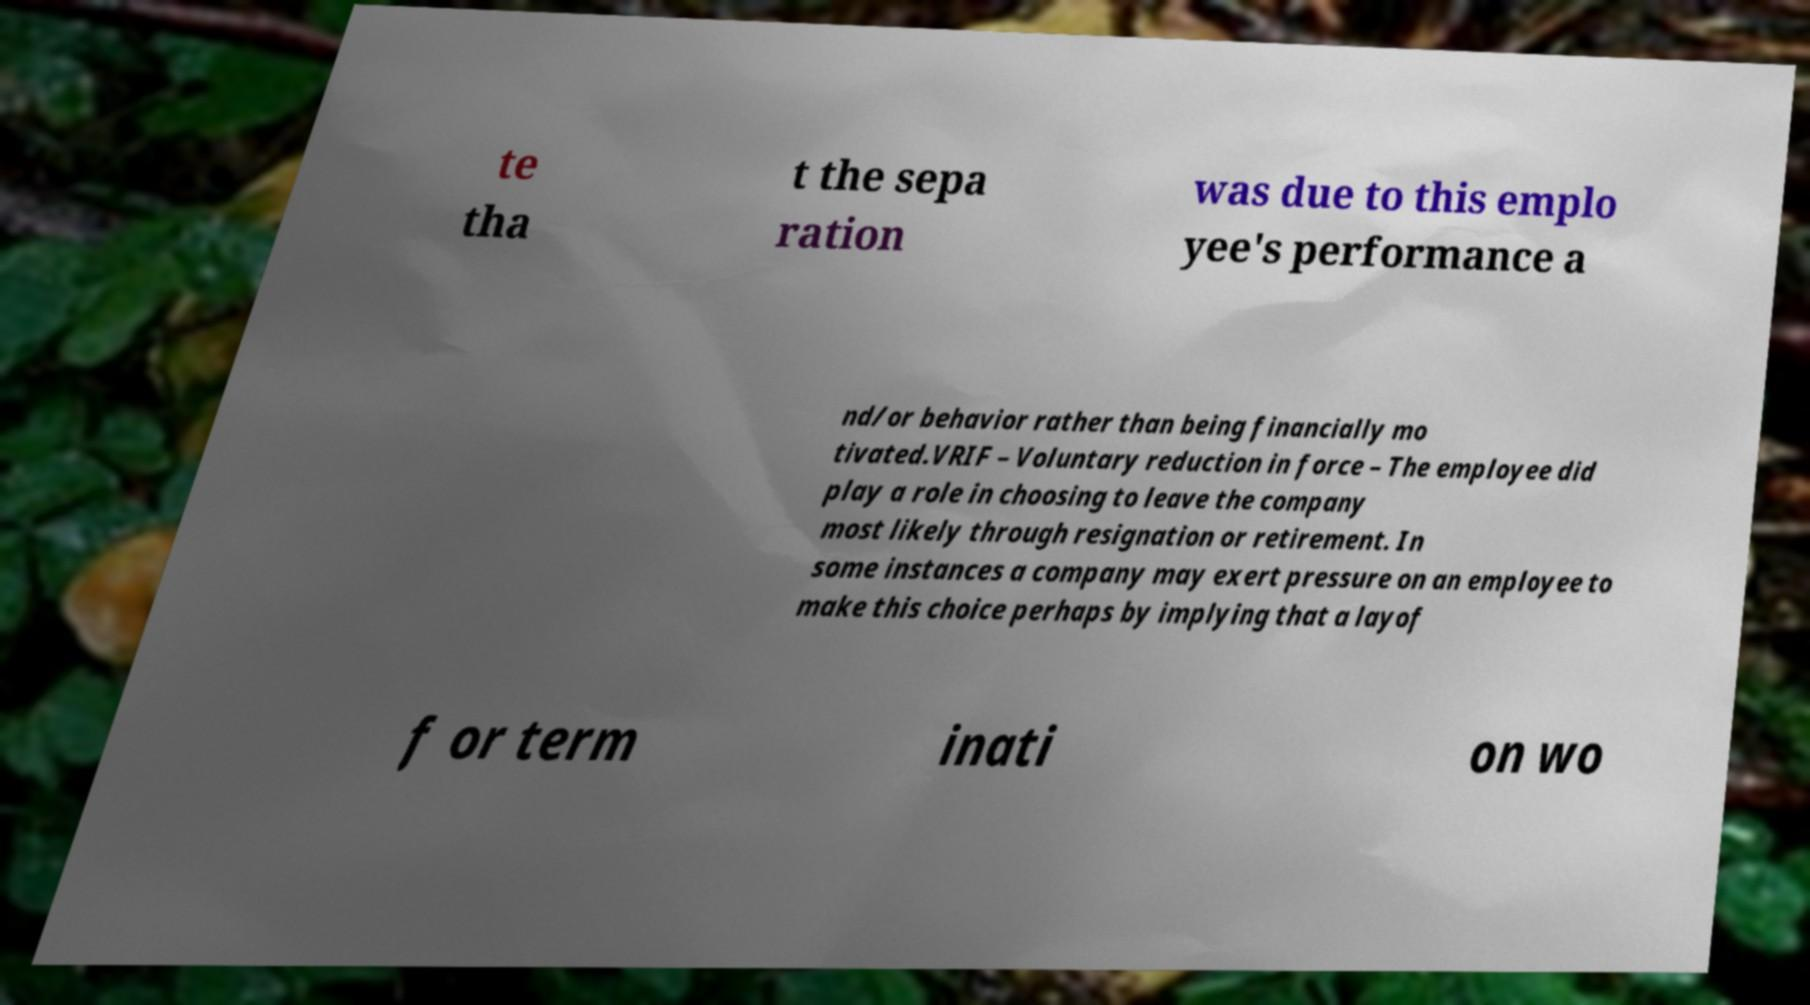Please identify and transcribe the text found in this image. te tha t the sepa ration was due to this emplo yee's performance a nd/or behavior rather than being financially mo tivated.VRIF – Voluntary reduction in force – The employee did play a role in choosing to leave the company most likely through resignation or retirement. In some instances a company may exert pressure on an employee to make this choice perhaps by implying that a layof f or term inati on wo 